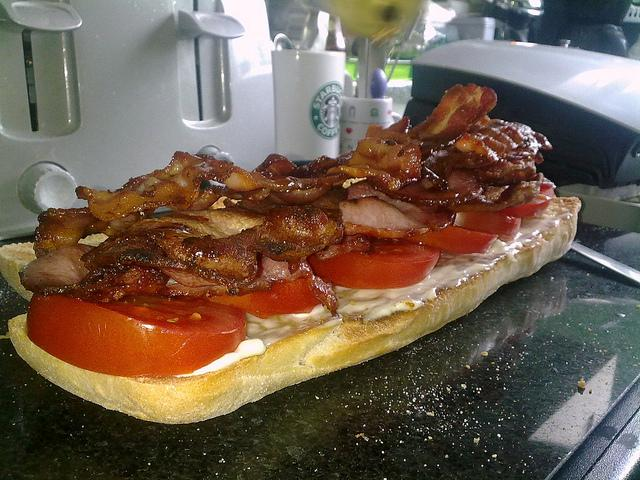What is missing to make a classic sandwich?

Choices:
A) mustard
B) pickles
C) onions
D) lettuce lettuce 